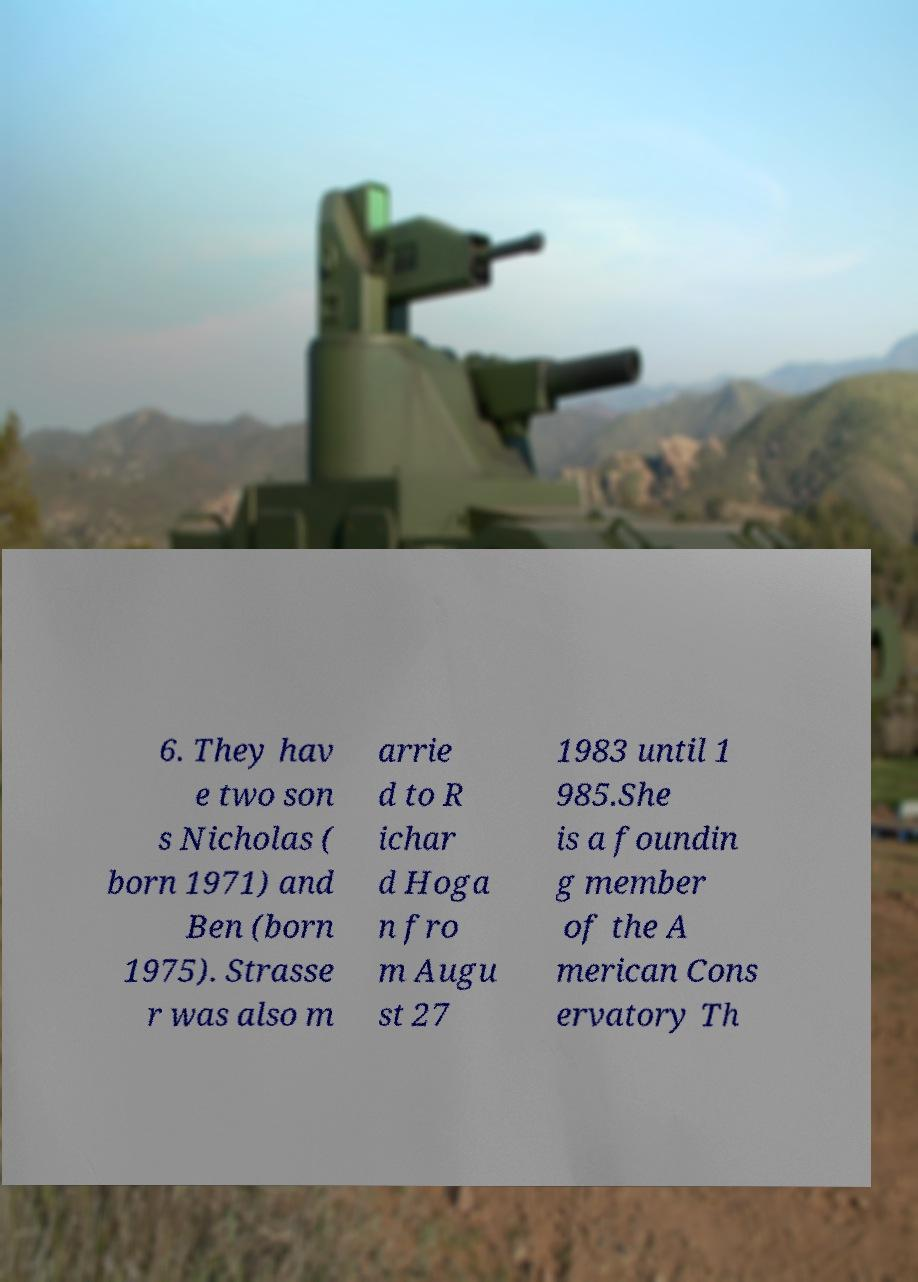Can you read and provide the text displayed in the image?This photo seems to have some interesting text. Can you extract and type it out for me? 6. They hav e two son s Nicholas ( born 1971) and Ben (born 1975). Strasse r was also m arrie d to R ichar d Hoga n fro m Augu st 27 1983 until 1 985.She is a foundin g member of the A merican Cons ervatory Th 